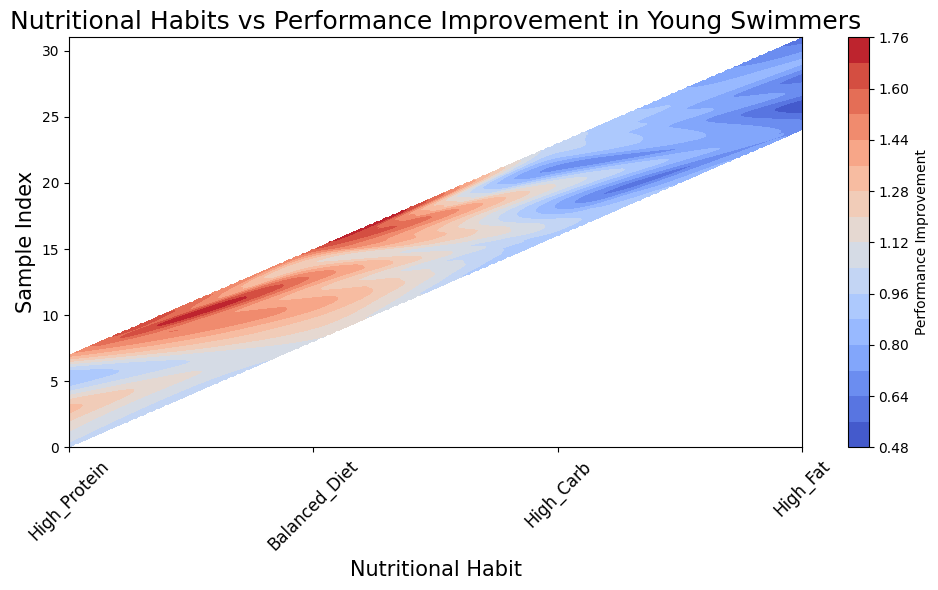What nutritional habit is associated with the highest performance improvement on average? Observe the contour levels and colors. The "Balanced Diet" category has higher average performance improvement as indicated by more red or warmer colors compared to other categories.
Answer: Balanced Diet Is there a pronounced difference in performance improvement between High Protein and High Carb diets? Compare the visual colors in the contour plot. High Protein areas have more warm colors (reds and oranges) indicating higher performance improvements, while High Carb has mostly cooler colors (blues), indicating lower improvements.
Answer: Yes Which nutritional habit has the least variability in performance improvement? Look at the spread and variation in the contour colors within each category. The "High Fat" category has mostly consistent cooler colors, indicating less variability.
Answer: High Fat How does the performance improvement in Balanced Diet compare to High Fat? Compare the range of colors in both categories. "Balanced Diet" has warmer colors, indicating higher improvements, while "High Fat" has cooler colors, indicating lower improvements.
Answer: Balanced Diet has higher performance improvement than High Fat If you were to choose between High Protein and Balanced Diet, which one would you choose for better performance improvement? Both categories show warm colors, but "Balanced Diet" has slightly more intense warm colors indicating better performance improvements.
Answer: Balanced Diet Looking at the contour plot, can you identify which nutritional habit tends to have a performance improvement close to 1.0 the most frequently? Observe the contour levels around the value 1.0. "High Protein" has more colors around the middle range (yellows), which indicates frequent performance improvements around 1.0.
Answer: High Protein Compared to High Fat, how does a High Carb diet affect performance improvement? High Carb shows a mix of cooler and some warmer colors compared to uniformly cool colors in High Fat. This indicates slight but generally higher performance improvements in High Carb.
Answer: High Carb has generally higher performance improvement than High Fat What's the median performance improvement indicator for a Balanced Diet? The range of colors (mostly warm) in the Balanced Diet area indicates the performance improvement is higher, often around 1.3 or 1.4. The median would fall around these values due to the color distribution.
Answer: Approximately 1.3-1.4 Is there any visual evidence suggesting that a High Fat diet should be avoided? The "High Fat" category is filled with cooler colors, indicating lower performance improvement values. This visual depiction suggests it's less optimal compared to other diets.
Answer: Yes What is the relative position of High Protein and High Fat diets in terms of sample index and performance improvement? High Protein data points are visually spread across higher sample index values with warm colors indicating better improvement, while High Fat points are more clustered with cooler colors.
Answer: High Protein is better positioned than High Fat 